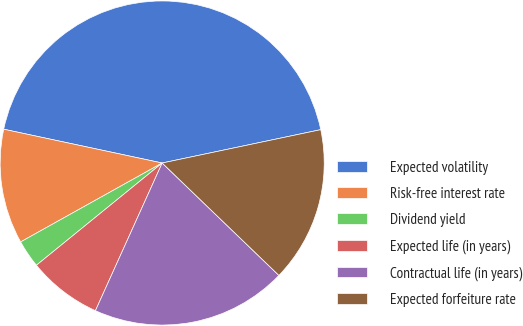Convert chart to OTSL. <chart><loc_0><loc_0><loc_500><loc_500><pie_chart><fcel>Expected volatility<fcel>Risk-free interest rate<fcel>Dividend yield<fcel>Expected life (in years)<fcel>Contractual life (in years)<fcel>Expected forfeiture rate<nl><fcel>43.36%<fcel>11.44%<fcel>2.77%<fcel>7.38%<fcel>19.56%<fcel>15.5%<nl></chart> 